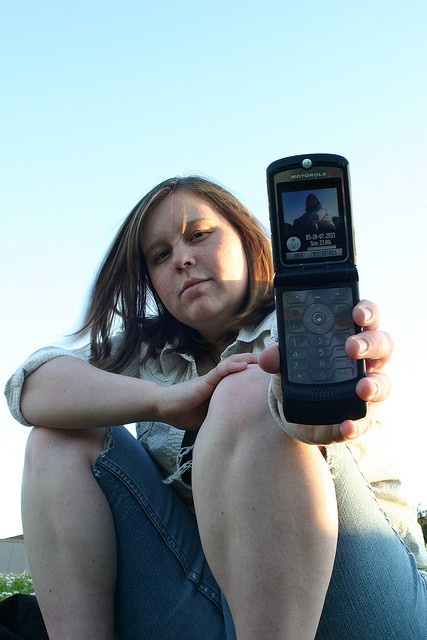Describe the objects in this image and their specific colors. I can see people in lightblue, gray, black, darkgray, and ivory tones and cell phone in lightblue, black, darkblue, blue, and gray tones in this image. 